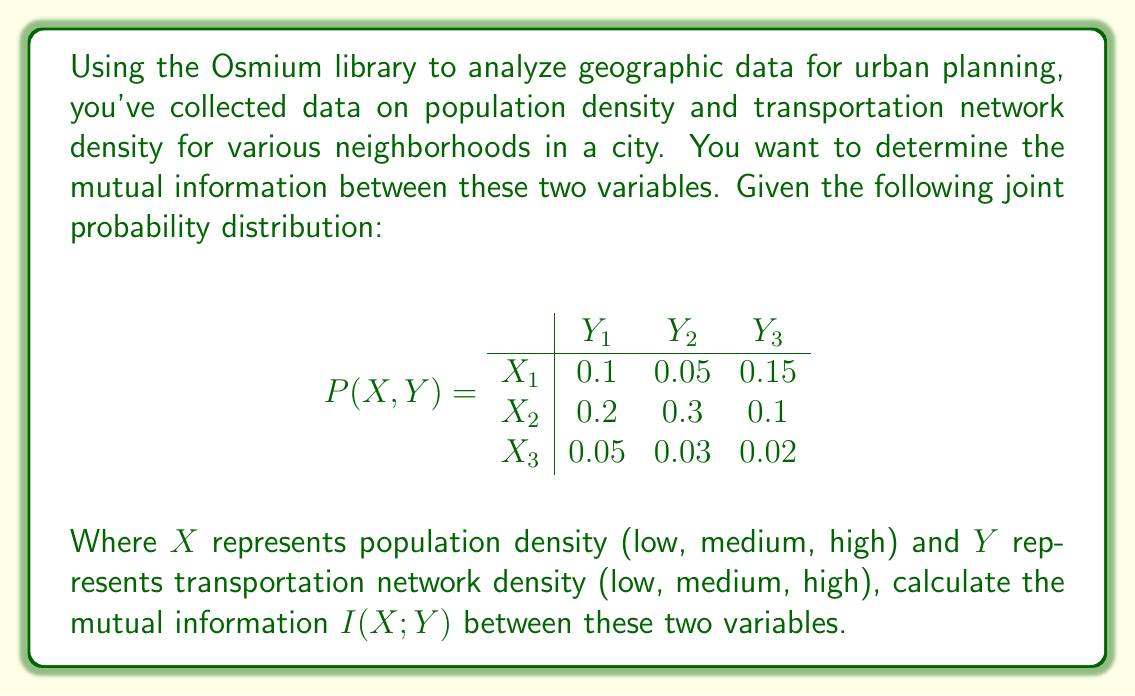Give your solution to this math problem. To calculate the mutual information $I(X;Y)$, we need to follow these steps:

1. Calculate the marginal probabilities $P(X)$ and $P(Y)$
2. Calculate the entropy of X: $H(X)$
3. Calculate the conditional entropy of X given Y: $H(X|Y)$
4. Calculate the mutual information: $I(X;Y) = H(X) - H(X|Y)$

Step 1: Calculate marginal probabilities

For $P(X)$:
$P(X_1) = 0.1 + 0.05 + 0.15 = 0.3$
$P(X_2) = 0.2 + 0.3 + 0.1 = 0.6$
$P(X_3) = 0.05 + 0.03 + 0.02 = 0.1$

For $P(Y)$:
$P(Y_1) = 0.1 + 0.2 + 0.05 = 0.35$
$P(Y_2) = 0.05 + 0.3 + 0.03 = 0.38$
$P(Y_3) = 0.15 + 0.1 + 0.02 = 0.27$

Step 2: Calculate $H(X)$

$$H(X) = -\sum_{i} P(X_i) \log_2 P(X_i)$$
$$H(X) = -[0.3 \log_2 0.3 + 0.6 \log_2 0.6 + 0.1 \log_2 0.1]$$
$$H(X) \approx 1.2955 \text{ bits}$$

Step 3: Calculate $H(X|Y)$

$$H(X|Y) = -\sum_{i,j} P(X_i, Y_j) \log_2 \frac{P(X_i, Y_j)}{P(Y_j)}$$

Calculating each term:

$P(X_1, Y_1) \log_2 \frac{P(X_1, Y_1)}{P(Y_1)} = 0.1 \log_2 \frac{0.1}{0.35} \approx -0.1844$
$P(X_1, Y_2) \log_2 \frac{P(X_1, Y_2)}{P(Y_2)} = 0.05 \log_2 \frac{0.05}{0.38} \approx -0.1453$
$P(X_1, Y_3) \log_2 \frac{P(X_1, Y_3)}{P(Y_3)} = 0.15 \log_2 \frac{0.15}{0.27} \approx -0.0927$

$P(X_2, Y_1) \log_2 \frac{P(X_2, Y_1)}{P(Y_1)} = 0.2 \log_2 \frac{0.2}{0.35} \approx -0.1375$
$P(X_2, Y_2) \log_2 \frac{P(X_2, Y_2)}{P(Y_2)} = 0.3 \log_2 \frac{0.3}{0.38} \approx -0.0457$
$P(X_2, Y_3) \log_2 \frac{P(X_2, Y_3)}{P(Y_3)} = 0.1 \log_2 \frac{0.1}{0.27} \approx -0.1427$

$P(X_3, Y_1) \log_2 \frac{P(X_3, Y_1)}{P(Y_1)} = 0.05 \log_2 \frac{0.05}{0.35} \approx -0.1453$
$P(X_3, Y_2) \log_2 \frac{P(X_3, Y_2)}{P(Y_2)} = 0.03 \log_2 \frac{0.03}{0.38} \approx -0.1266$
$P(X_3, Y_3) \log_2 \frac{P(X_3, Y_3)}{P(Y_3)} = 0.02 \log_2 \frac{0.02}{0.27} \approx -0.1042$

Summing these terms and negating:

$$H(X|Y) \approx 1.1244 \text{ bits}$$

Step 4: Calculate $I(X;Y)$

$$I(X;Y) = H(X) - H(X|Y)$$
$$I(X;Y) = 1.2955 - 1.1244 \approx 0.1711 \text{ bits}$$
Answer: The mutual information $I(X;Y)$ between population density and transportation network density is approximately 0.1711 bits. 